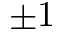<formula> <loc_0><loc_0><loc_500><loc_500>\pm 1</formula> 